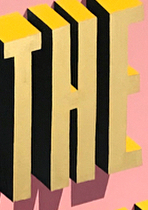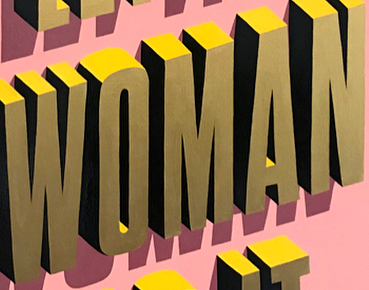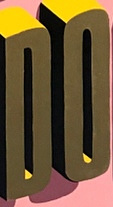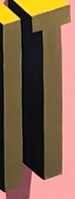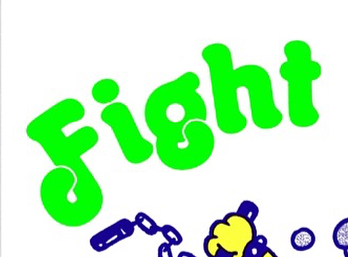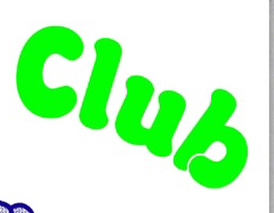What words are shown in these images in order, separated by a semicolon? THE; WOMAN; DO; IT; Fight; Club 